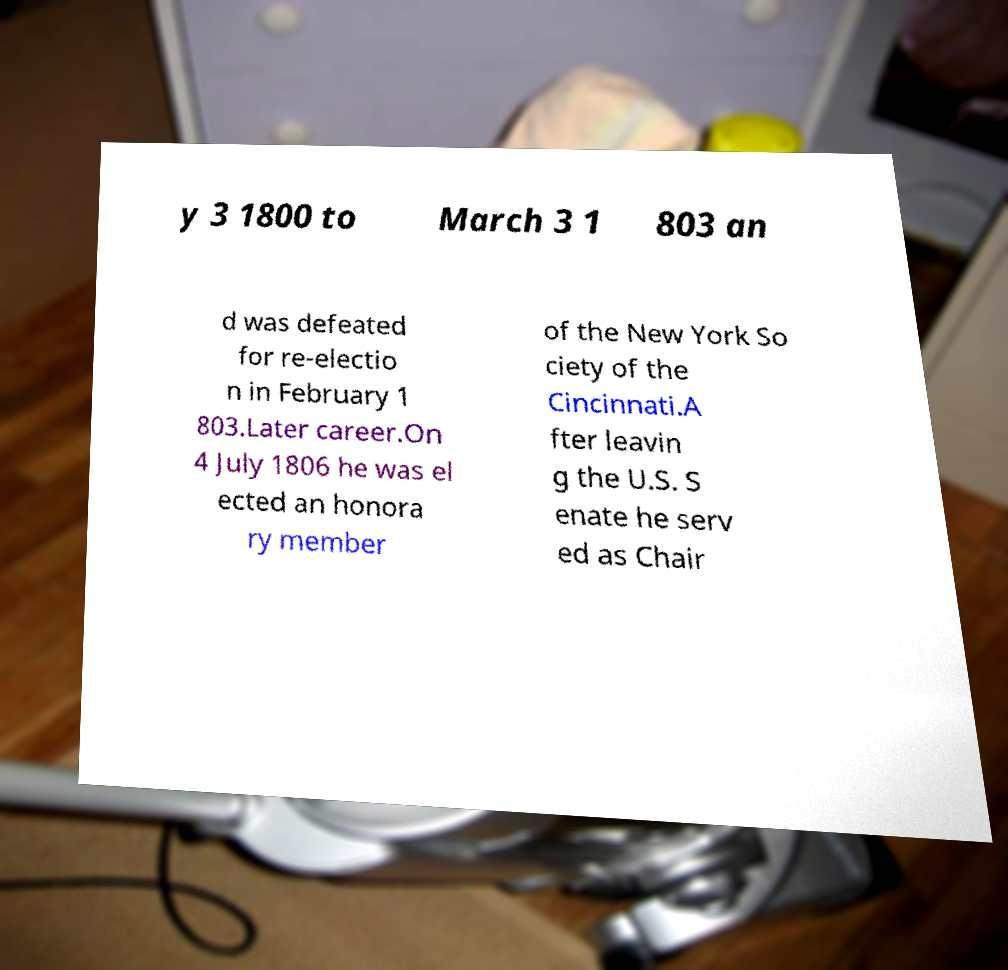Can you accurately transcribe the text from the provided image for me? y 3 1800 to March 3 1 803 an d was defeated for re-electio n in February 1 803.Later career.On 4 July 1806 he was el ected an honora ry member of the New York So ciety of the Cincinnati.A fter leavin g the U.S. S enate he serv ed as Chair 